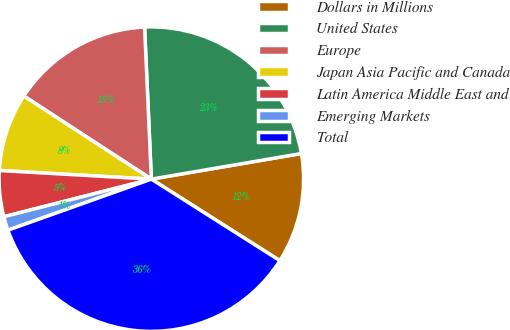Convert chart to OTSL. <chart><loc_0><loc_0><loc_500><loc_500><pie_chart><fcel>Dollars in Millions<fcel>United States<fcel>Europe<fcel>Japan Asia Pacific and Canada<fcel>Latin America Middle East and<fcel>Emerging Markets<fcel>Total<nl><fcel>11.69%<fcel>23.02%<fcel>15.1%<fcel>8.29%<fcel>4.88%<fcel>1.47%<fcel>35.56%<nl></chart> 